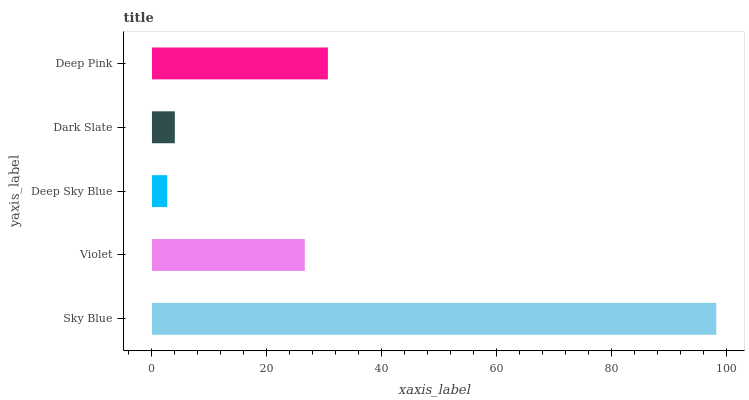Is Deep Sky Blue the minimum?
Answer yes or no. Yes. Is Sky Blue the maximum?
Answer yes or no. Yes. Is Violet the minimum?
Answer yes or no. No. Is Violet the maximum?
Answer yes or no. No. Is Sky Blue greater than Violet?
Answer yes or no. Yes. Is Violet less than Sky Blue?
Answer yes or no. Yes. Is Violet greater than Sky Blue?
Answer yes or no. No. Is Sky Blue less than Violet?
Answer yes or no. No. Is Violet the high median?
Answer yes or no. Yes. Is Violet the low median?
Answer yes or no. Yes. Is Deep Sky Blue the high median?
Answer yes or no. No. Is Deep Sky Blue the low median?
Answer yes or no. No. 